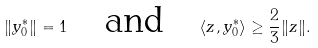<formula> <loc_0><loc_0><loc_500><loc_500>\| y ^ { * } _ { 0 } \| = 1 \quad \text {and} \quad \langle z , y ^ { * } _ { 0 } \rangle \geq \frac { 2 } { 3 } \| z \| .</formula> 